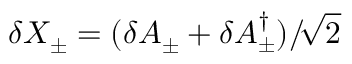Convert formula to latex. <formula><loc_0><loc_0><loc_500><loc_500>\delta X _ { \pm } = ( \delta A _ { \pm } + \delta A _ { \pm } ^ { \dagger } ) / \, \sqrt { 2 }</formula> 